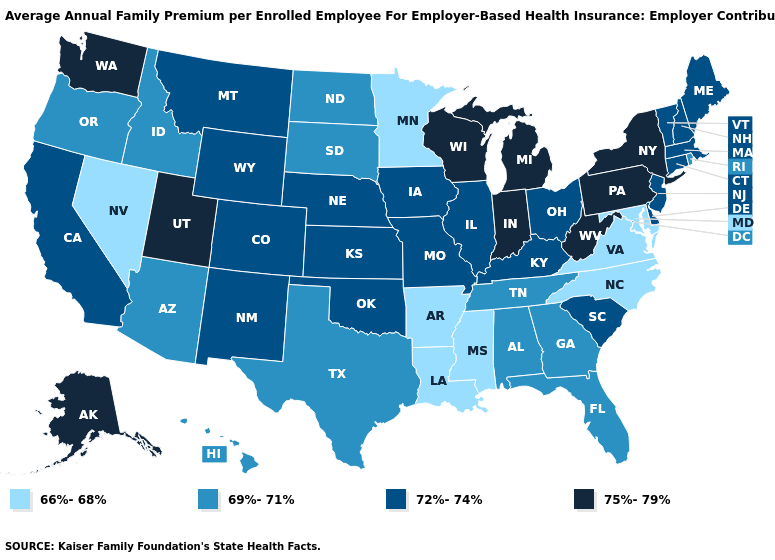What is the value of Montana?
Be succinct. 72%-74%. What is the value of South Carolina?
Concise answer only. 72%-74%. Is the legend a continuous bar?
Concise answer only. No. What is the value of Massachusetts?
Be succinct. 72%-74%. Which states have the lowest value in the USA?
Write a very short answer. Arkansas, Louisiana, Maryland, Minnesota, Mississippi, Nevada, North Carolina, Virginia. What is the value of Montana?
Be succinct. 72%-74%. Does Nevada have a lower value than Virginia?
Answer briefly. No. Which states have the highest value in the USA?
Be succinct. Alaska, Indiana, Michigan, New York, Pennsylvania, Utah, Washington, West Virginia, Wisconsin. Which states hav the highest value in the Northeast?
Short answer required. New York, Pennsylvania. What is the value of Missouri?
Quick response, please. 72%-74%. Is the legend a continuous bar?
Concise answer only. No. What is the value of Wisconsin?
Write a very short answer. 75%-79%. Is the legend a continuous bar?
Short answer required. No. What is the value of Oklahoma?
Concise answer only. 72%-74%. Does the map have missing data?
Concise answer only. No. 